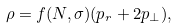<formula> <loc_0><loc_0><loc_500><loc_500>\rho = f ( N , \sigma ) ( p _ { r } + 2 p _ { \perp } ) ,</formula> 